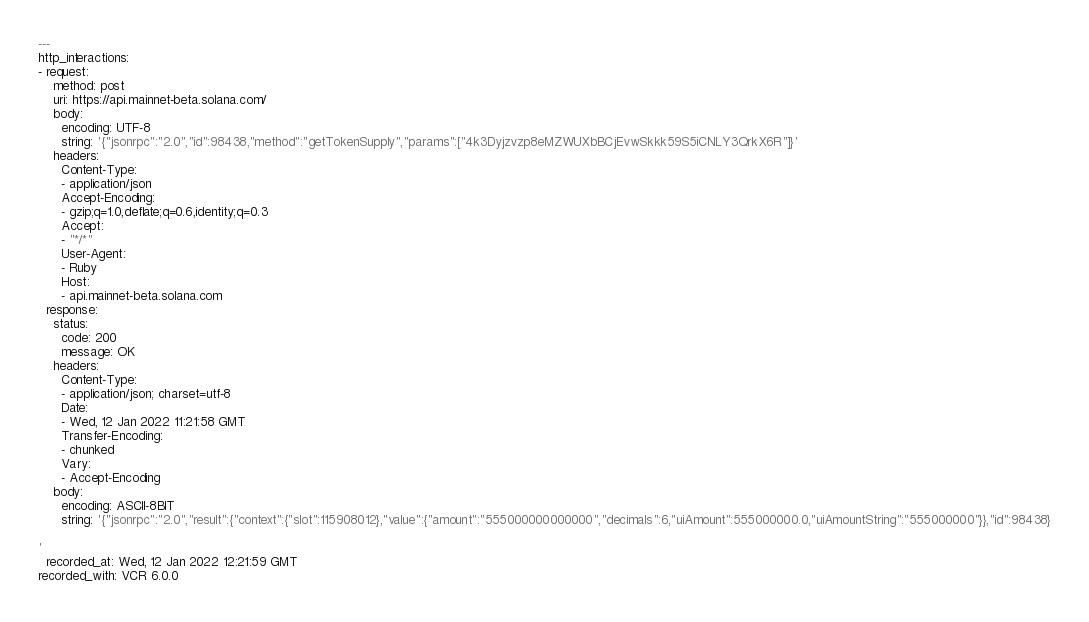Convert code to text. <code><loc_0><loc_0><loc_500><loc_500><_YAML_>---
http_interactions:
- request:
    method: post
    uri: https://api.mainnet-beta.solana.com/
    body:
      encoding: UTF-8
      string: '{"jsonrpc":"2.0","id":98438,"method":"getTokenSupply","params":["4k3Dyjzvzp8eMZWUXbBCjEvwSkkk59S5iCNLY3QrkX6R"]}'
    headers:
      Content-Type:
      - application/json
      Accept-Encoding:
      - gzip;q=1.0,deflate;q=0.6,identity;q=0.3
      Accept:
      - "*/*"
      User-Agent:
      - Ruby
      Host:
      - api.mainnet-beta.solana.com
  response:
    status:
      code: 200
      message: OK
    headers:
      Content-Type:
      - application/json; charset=utf-8
      Date:
      - Wed, 12 Jan 2022 11:21:58 GMT
      Transfer-Encoding:
      - chunked
      Vary:
      - Accept-Encoding
    body:
      encoding: ASCII-8BIT
      string: '{"jsonrpc":"2.0","result":{"context":{"slot":115908012},"value":{"amount":"555000000000000","decimals":6,"uiAmount":555000000.0,"uiAmountString":"555000000"}},"id":98438}

'
  recorded_at: Wed, 12 Jan 2022 12:21:59 GMT
recorded_with: VCR 6.0.0
</code> 